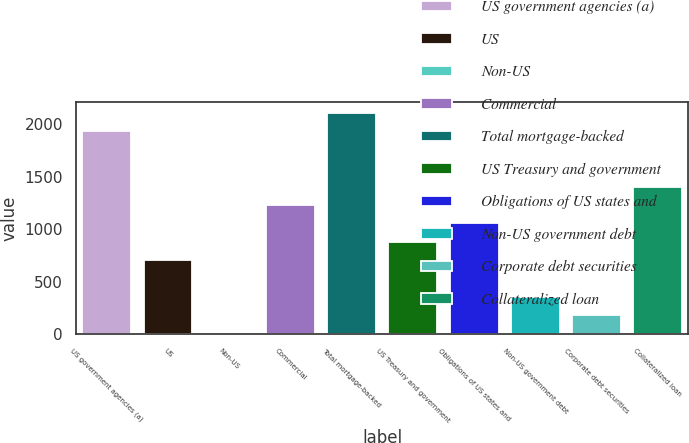Convert chart to OTSL. <chart><loc_0><loc_0><loc_500><loc_500><bar_chart><fcel>US government agencies (a)<fcel>US<fcel>Non-US<fcel>Commercial<fcel>Total mortgage-backed<fcel>US Treasury and government<fcel>Obligations of US states and<fcel>Non-US government debt<fcel>Corporate debt securities<fcel>Collateralized loan<nl><fcel>1933.2<fcel>706.8<fcel>6<fcel>1232.4<fcel>2108.4<fcel>882<fcel>1057.2<fcel>356.4<fcel>181.2<fcel>1407.6<nl></chart> 